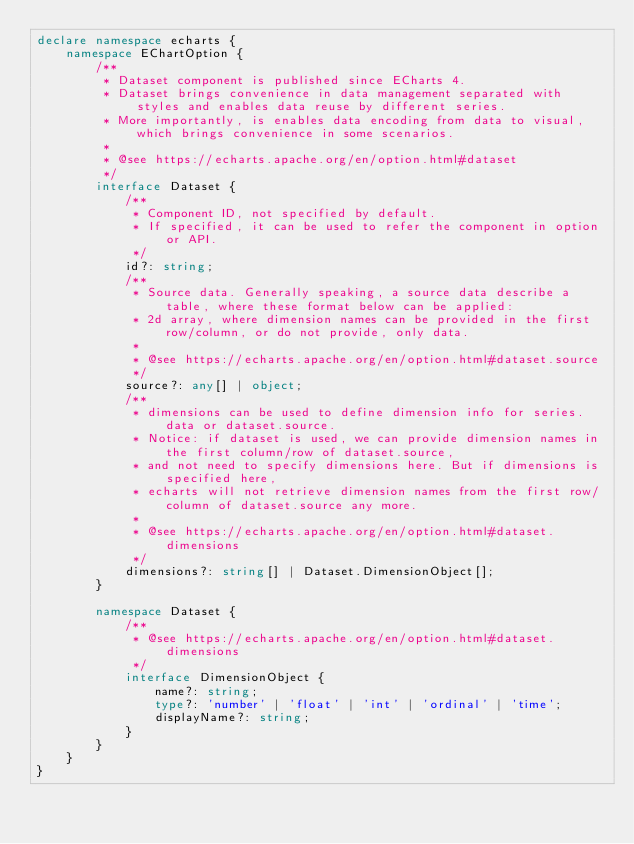<code> <loc_0><loc_0><loc_500><loc_500><_TypeScript_>declare namespace echarts {
    namespace EChartOption {
        /**
         * Dataset component is published since ECharts 4.
         * Dataset brings convenience in data management separated with styles and enables data reuse by different series.
         * More importantly, is enables data encoding from data to visual, which brings convenience in some scenarios.
         *
         * @see https://echarts.apache.org/en/option.html#dataset
         */
        interface Dataset {
            /**
             * Component ID, not specified by default.
             * If specified, it can be used to refer the component in option or API.
             */
            id?: string;
            /**
             * Source data. Generally speaking, a source data describe a table, where these format below can be applied:
             * 2d array, where dimension names can be provided in the first row/column, or do not provide, only data.
             *
             * @see https://echarts.apache.org/en/option.html#dataset.source
             */
            source?: any[] | object;
            /**
             * dimensions can be used to define dimension info for series.data or dataset.source.
             * Notice: if dataset is used, we can provide dimension names in the first column/row of dataset.source,
             * and not need to specify dimensions here. But if dimensions is specified here,
             * echarts will not retrieve dimension names from the first row/column of dataset.source any more.
             *
             * @see https://echarts.apache.org/en/option.html#dataset.dimensions
             */
            dimensions?: string[] | Dataset.DimensionObject[];
        }

        namespace Dataset {
            /**
             * @see https://echarts.apache.org/en/option.html#dataset.dimensions
             */
            interface DimensionObject {
                name?: string;
                type?: 'number' | 'float' | 'int' | 'ordinal' | 'time';
                displayName?: string;
            }
        }
    }
}
</code> 